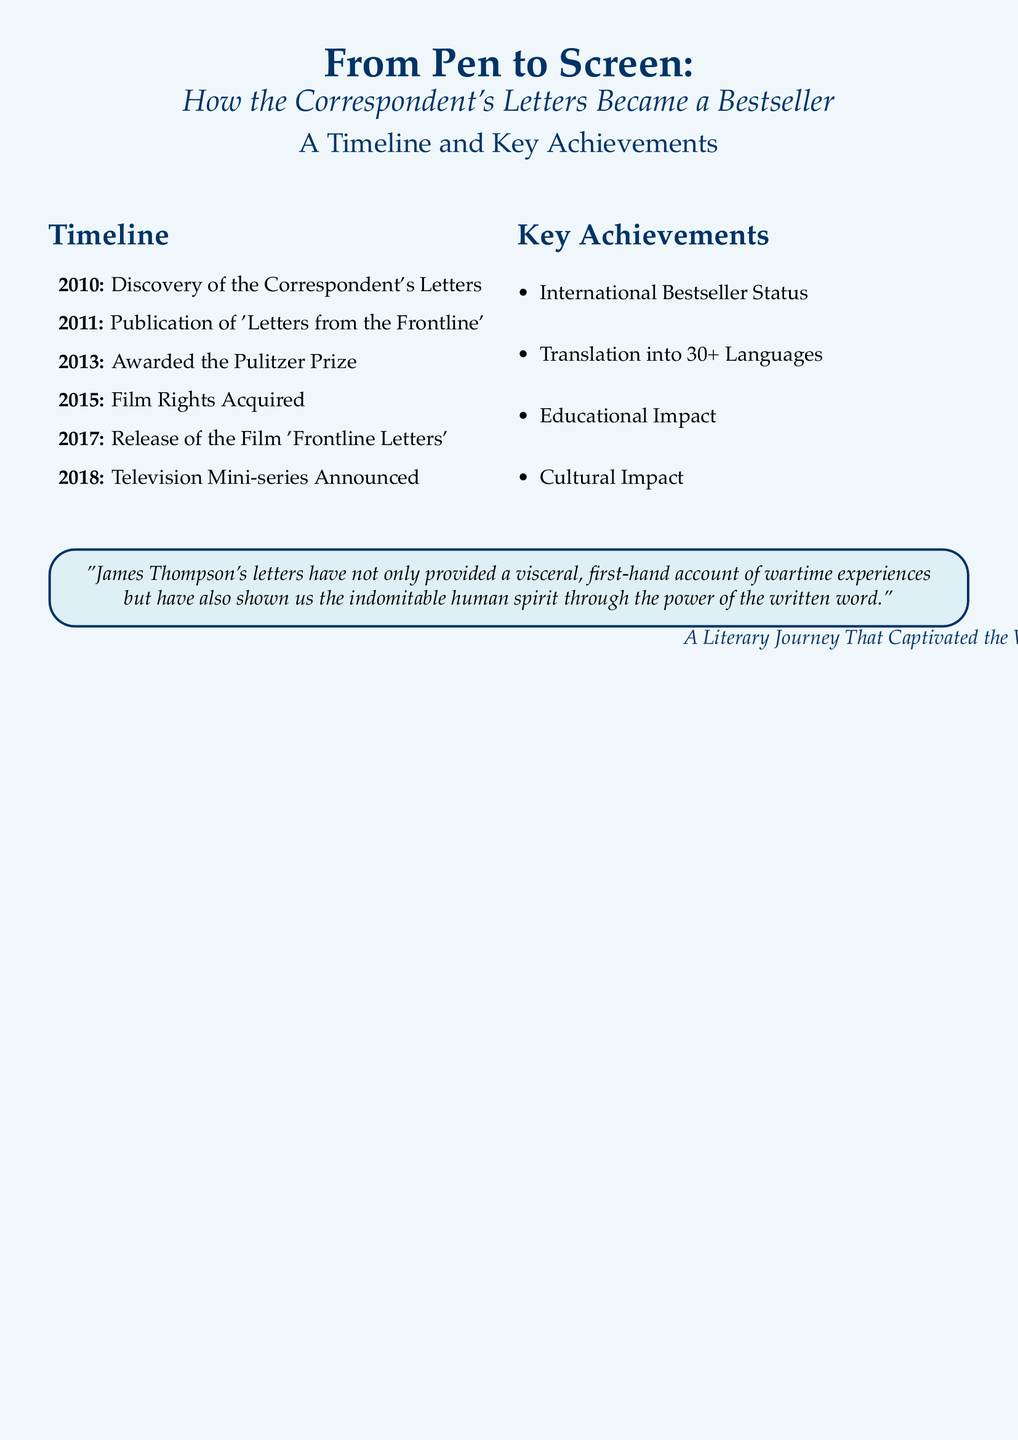What year were the Correspondent's Letters discovered? The document explicitly states the year of discovery as 2010.
Answer: 2010 What is the title of the publication that followed the discovery? The document lists 'Letters from the Frontline' as the publication following the discovery of the letters.
Answer: Letters from the Frontline Which prestigious award was won in 2013? According to the timeline, the Correspondent's Letters were awarded the Pulitzer Prize in 2013.
Answer: Pulitzer Prize How many languages were the letters translated into? The document indicates that the letters were translated into over 30 languages.
Answer: 30+ What major event occurred in 2017? The timeline mentions the release of the film 'Frontline Letters' as a significant milestone in 2017.
Answer: Release of the Film 'Frontline Letters' What is one of the key achievements mentioned related to educational impact? The document highlights "Educational Impact" as one of the key achievements of the Correspondent's letters.
Answer: Educational Impact What type of media adaptation was announced in 2018? The document states that a television mini-series was announced in 2018.
Answer: Television Mini-series Announced What does James Thompson's letters demonstrate according to the quote? The quote emphasizes the indomitable human spirit through the power of the written word as demonstrated by the letters.
Answer: Indomitable human spirit What color is the background of the document? The document specifies that the page color is light blue.
Answer: Light blue 